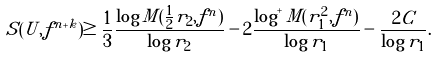Convert formula to latex. <formula><loc_0><loc_0><loc_500><loc_500>S ( U , f ^ { n + k } ) \geq \frac { 1 } { 3 } \frac { \log M ( \frac { 1 } { 2 } r _ { 2 } , f ^ { n } ) } { \log r _ { 2 } } - 2 \frac { \log ^ { + } M ( r _ { 1 } ^ { 2 } , f ^ { n } ) } { \log r _ { 1 } } - \frac { 2 C } { \log r _ { 1 } } .</formula> 